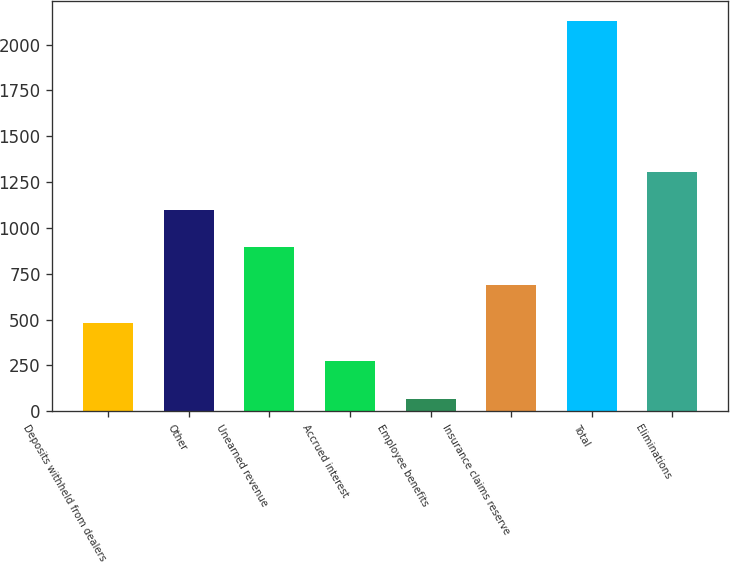Convert chart. <chart><loc_0><loc_0><loc_500><loc_500><bar_chart><fcel>Deposits withheld from dealers<fcel>Other<fcel>Unearned revenue<fcel>Accrued interest<fcel>Employee benefits<fcel>Insurance claims reserve<fcel>Total<fcel>Eliminations<nl><fcel>481.2<fcel>1099.5<fcel>893.4<fcel>275.1<fcel>69<fcel>687.3<fcel>2130<fcel>1305.6<nl></chart> 